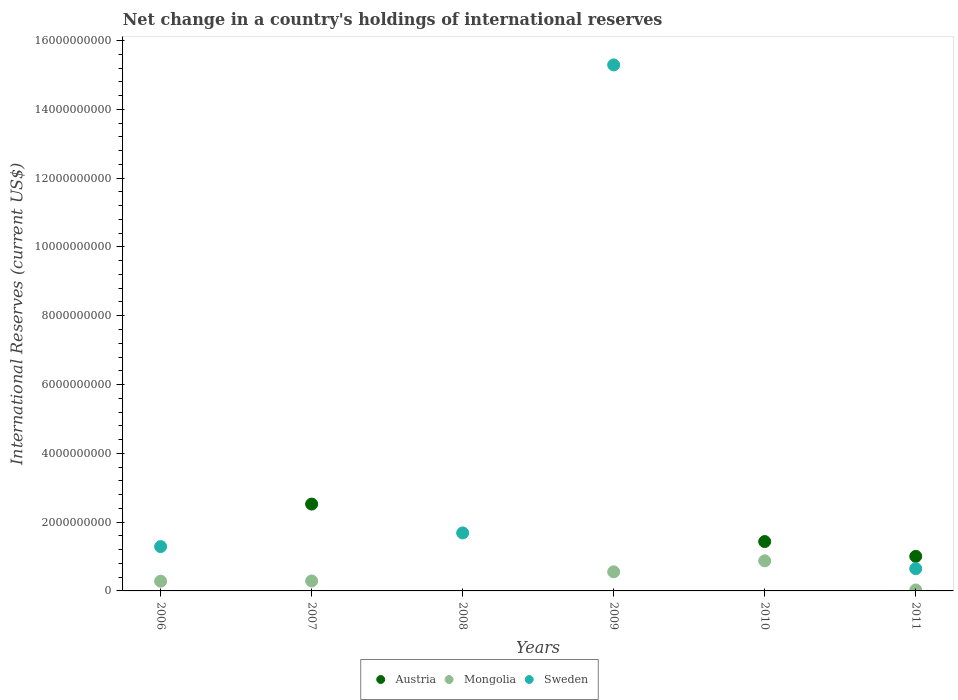How many different coloured dotlines are there?
Your answer should be very brief. 3. Across all years, what is the maximum international reserves in Mongolia?
Make the answer very short. 8.75e+08. Across all years, what is the minimum international reserves in Austria?
Offer a terse response. 0. In which year was the international reserves in Mongolia maximum?
Keep it short and to the point. 2010. What is the total international reserves in Austria in the graph?
Provide a short and direct response. 4.96e+09. What is the difference between the international reserves in Austria in 2010 and that in 2011?
Give a very brief answer. 4.30e+08. What is the difference between the international reserves in Sweden in 2006 and the international reserves in Mongolia in 2010?
Give a very brief answer. 4.14e+08. What is the average international reserves in Sweden per year?
Your answer should be compact. 3.15e+09. In the year 2011, what is the difference between the international reserves in Austria and international reserves in Sweden?
Offer a very short reply. 3.58e+08. In how many years, is the international reserves in Mongolia greater than 5600000000 US$?
Keep it short and to the point. 0. What is the ratio of the international reserves in Sweden in 2009 to that in 2011?
Provide a short and direct response. 23.65. Is the international reserves in Mongolia in 2010 less than that in 2011?
Make the answer very short. No. What is the difference between the highest and the second highest international reserves in Sweden?
Give a very brief answer. 1.36e+1. What is the difference between the highest and the lowest international reserves in Mongolia?
Make the answer very short. 8.75e+08. In how many years, is the international reserves in Austria greater than the average international reserves in Austria taken over all years?
Provide a succinct answer. 3. Is the sum of the international reserves in Sweden in 2006 and 2008 greater than the maximum international reserves in Mongolia across all years?
Offer a very short reply. Yes. Is it the case that in every year, the sum of the international reserves in Austria and international reserves in Mongolia  is greater than the international reserves in Sweden?
Give a very brief answer. No. Does the international reserves in Sweden monotonically increase over the years?
Offer a very short reply. No. Is the international reserves in Sweden strictly greater than the international reserves in Mongolia over the years?
Ensure brevity in your answer.  No. Is the international reserves in Sweden strictly less than the international reserves in Mongolia over the years?
Provide a short and direct response. No. How many years are there in the graph?
Give a very brief answer. 6. Are the values on the major ticks of Y-axis written in scientific E-notation?
Give a very brief answer. No. Does the graph contain grids?
Ensure brevity in your answer.  No. Where does the legend appear in the graph?
Your answer should be very brief. Bottom center. How many legend labels are there?
Keep it short and to the point. 3. What is the title of the graph?
Keep it short and to the point. Net change in a country's holdings of international reserves. What is the label or title of the X-axis?
Your response must be concise. Years. What is the label or title of the Y-axis?
Your answer should be very brief. International Reserves (current US$). What is the International Reserves (current US$) in Austria in 2006?
Your answer should be compact. 0. What is the International Reserves (current US$) in Mongolia in 2006?
Make the answer very short. 2.83e+08. What is the International Reserves (current US$) of Sweden in 2006?
Give a very brief answer. 1.29e+09. What is the International Reserves (current US$) of Austria in 2007?
Make the answer very short. 2.53e+09. What is the International Reserves (current US$) of Mongolia in 2007?
Keep it short and to the point. 2.89e+08. What is the International Reserves (current US$) of Sweden in 2008?
Give a very brief answer. 1.69e+09. What is the International Reserves (current US$) of Mongolia in 2009?
Provide a succinct answer. 5.55e+08. What is the International Reserves (current US$) in Sweden in 2009?
Your answer should be very brief. 1.53e+1. What is the International Reserves (current US$) of Austria in 2010?
Offer a terse response. 1.44e+09. What is the International Reserves (current US$) in Mongolia in 2010?
Make the answer very short. 8.75e+08. What is the International Reserves (current US$) of Sweden in 2010?
Ensure brevity in your answer.  0. What is the International Reserves (current US$) of Austria in 2011?
Offer a very short reply. 1.00e+09. What is the International Reserves (current US$) in Mongolia in 2011?
Your response must be concise. 2.79e+07. What is the International Reserves (current US$) of Sweden in 2011?
Your answer should be very brief. 6.47e+08. Across all years, what is the maximum International Reserves (current US$) in Austria?
Offer a very short reply. 2.53e+09. Across all years, what is the maximum International Reserves (current US$) in Mongolia?
Ensure brevity in your answer.  8.75e+08. Across all years, what is the maximum International Reserves (current US$) in Sweden?
Make the answer very short. 1.53e+1. Across all years, what is the minimum International Reserves (current US$) of Austria?
Ensure brevity in your answer.  0. Across all years, what is the minimum International Reserves (current US$) in Mongolia?
Offer a very short reply. 0. What is the total International Reserves (current US$) of Austria in the graph?
Offer a terse response. 4.96e+09. What is the total International Reserves (current US$) of Mongolia in the graph?
Keep it short and to the point. 2.03e+09. What is the total International Reserves (current US$) in Sweden in the graph?
Ensure brevity in your answer.  1.89e+1. What is the difference between the International Reserves (current US$) in Mongolia in 2006 and that in 2007?
Give a very brief answer. -6.62e+06. What is the difference between the International Reserves (current US$) in Sweden in 2006 and that in 2008?
Give a very brief answer. -3.97e+08. What is the difference between the International Reserves (current US$) of Mongolia in 2006 and that in 2009?
Provide a succinct answer. -2.72e+08. What is the difference between the International Reserves (current US$) in Sweden in 2006 and that in 2009?
Offer a terse response. -1.40e+1. What is the difference between the International Reserves (current US$) of Mongolia in 2006 and that in 2010?
Give a very brief answer. -5.92e+08. What is the difference between the International Reserves (current US$) of Mongolia in 2006 and that in 2011?
Your answer should be compact. 2.55e+08. What is the difference between the International Reserves (current US$) of Sweden in 2006 and that in 2011?
Give a very brief answer. 6.42e+08. What is the difference between the International Reserves (current US$) in Mongolia in 2007 and that in 2009?
Your answer should be compact. -2.66e+08. What is the difference between the International Reserves (current US$) of Austria in 2007 and that in 2010?
Your answer should be very brief. 1.09e+09. What is the difference between the International Reserves (current US$) in Mongolia in 2007 and that in 2010?
Offer a terse response. -5.86e+08. What is the difference between the International Reserves (current US$) in Austria in 2007 and that in 2011?
Your response must be concise. 1.52e+09. What is the difference between the International Reserves (current US$) of Mongolia in 2007 and that in 2011?
Give a very brief answer. 2.61e+08. What is the difference between the International Reserves (current US$) in Sweden in 2008 and that in 2009?
Offer a very short reply. -1.36e+1. What is the difference between the International Reserves (current US$) of Sweden in 2008 and that in 2011?
Give a very brief answer. 1.04e+09. What is the difference between the International Reserves (current US$) in Mongolia in 2009 and that in 2010?
Your answer should be compact. -3.20e+08. What is the difference between the International Reserves (current US$) of Mongolia in 2009 and that in 2011?
Your response must be concise. 5.27e+08. What is the difference between the International Reserves (current US$) in Sweden in 2009 and that in 2011?
Provide a succinct answer. 1.46e+1. What is the difference between the International Reserves (current US$) in Austria in 2010 and that in 2011?
Offer a terse response. 4.30e+08. What is the difference between the International Reserves (current US$) of Mongolia in 2010 and that in 2011?
Make the answer very short. 8.47e+08. What is the difference between the International Reserves (current US$) in Mongolia in 2006 and the International Reserves (current US$) in Sweden in 2008?
Offer a very short reply. -1.40e+09. What is the difference between the International Reserves (current US$) in Mongolia in 2006 and the International Reserves (current US$) in Sweden in 2009?
Ensure brevity in your answer.  -1.50e+1. What is the difference between the International Reserves (current US$) in Mongolia in 2006 and the International Reserves (current US$) in Sweden in 2011?
Ensure brevity in your answer.  -3.64e+08. What is the difference between the International Reserves (current US$) in Austria in 2007 and the International Reserves (current US$) in Sweden in 2008?
Offer a terse response. 8.39e+08. What is the difference between the International Reserves (current US$) in Mongolia in 2007 and the International Reserves (current US$) in Sweden in 2008?
Ensure brevity in your answer.  -1.40e+09. What is the difference between the International Reserves (current US$) of Austria in 2007 and the International Reserves (current US$) of Mongolia in 2009?
Offer a very short reply. 1.97e+09. What is the difference between the International Reserves (current US$) of Austria in 2007 and the International Reserves (current US$) of Sweden in 2009?
Your response must be concise. -1.28e+1. What is the difference between the International Reserves (current US$) of Mongolia in 2007 and the International Reserves (current US$) of Sweden in 2009?
Provide a short and direct response. -1.50e+1. What is the difference between the International Reserves (current US$) of Austria in 2007 and the International Reserves (current US$) of Mongolia in 2010?
Offer a very short reply. 1.65e+09. What is the difference between the International Reserves (current US$) in Austria in 2007 and the International Reserves (current US$) in Mongolia in 2011?
Your response must be concise. 2.50e+09. What is the difference between the International Reserves (current US$) in Austria in 2007 and the International Reserves (current US$) in Sweden in 2011?
Make the answer very short. 1.88e+09. What is the difference between the International Reserves (current US$) of Mongolia in 2007 and the International Reserves (current US$) of Sweden in 2011?
Ensure brevity in your answer.  -3.58e+08. What is the difference between the International Reserves (current US$) of Mongolia in 2009 and the International Reserves (current US$) of Sweden in 2011?
Give a very brief answer. -9.20e+07. What is the difference between the International Reserves (current US$) of Austria in 2010 and the International Reserves (current US$) of Mongolia in 2011?
Give a very brief answer. 1.41e+09. What is the difference between the International Reserves (current US$) of Austria in 2010 and the International Reserves (current US$) of Sweden in 2011?
Your response must be concise. 7.88e+08. What is the difference between the International Reserves (current US$) in Mongolia in 2010 and the International Reserves (current US$) in Sweden in 2011?
Your response must be concise. 2.28e+08. What is the average International Reserves (current US$) of Austria per year?
Offer a terse response. 8.27e+08. What is the average International Reserves (current US$) of Mongolia per year?
Make the answer very short. 3.38e+08. What is the average International Reserves (current US$) of Sweden per year?
Offer a very short reply. 3.15e+09. In the year 2006, what is the difference between the International Reserves (current US$) of Mongolia and International Reserves (current US$) of Sweden?
Make the answer very short. -1.01e+09. In the year 2007, what is the difference between the International Reserves (current US$) of Austria and International Reserves (current US$) of Mongolia?
Your response must be concise. 2.24e+09. In the year 2009, what is the difference between the International Reserves (current US$) in Mongolia and International Reserves (current US$) in Sweden?
Ensure brevity in your answer.  -1.47e+1. In the year 2010, what is the difference between the International Reserves (current US$) of Austria and International Reserves (current US$) of Mongolia?
Offer a terse response. 5.60e+08. In the year 2011, what is the difference between the International Reserves (current US$) of Austria and International Reserves (current US$) of Mongolia?
Provide a short and direct response. 9.77e+08. In the year 2011, what is the difference between the International Reserves (current US$) of Austria and International Reserves (current US$) of Sweden?
Your response must be concise. 3.58e+08. In the year 2011, what is the difference between the International Reserves (current US$) in Mongolia and International Reserves (current US$) in Sweden?
Your response must be concise. -6.19e+08. What is the ratio of the International Reserves (current US$) of Mongolia in 2006 to that in 2007?
Your response must be concise. 0.98. What is the ratio of the International Reserves (current US$) of Sweden in 2006 to that in 2008?
Make the answer very short. 0.76. What is the ratio of the International Reserves (current US$) in Mongolia in 2006 to that in 2009?
Your response must be concise. 0.51. What is the ratio of the International Reserves (current US$) of Sweden in 2006 to that in 2009?
Offer a very short reply. 0.08. What is the ratio of the International Reserves (current US$) in Mongolia in 2006 to that in 2010?
Keep it short and to the point. 0.32. What is the ratio of the International Reserves (current US$) of Mongolia in 2006 to that in 2011?
Your answer should be compact. 10.13. What is the ratio of the International Reserves (current US$) of Sweden in 2006 to that in 2011?
Offer a terse response. 1.99. What is the ratio of the International Reserves (current US$) of Mongolia in 2007 to that in 2009?
Offer a terse response. 0.52. What is the ratio of the International Reserves (current US$) in Austria in 2007 to that in 2010?
Provide a succinct answer. 1.76. What is the ratio of the International Reserves (current US$) of Mongolia in 2007 to that in 2010?
Keep it short and to the point. 0.33. What is the ratio of the International Reserves (current US$) in Austria in 2007 to that in 2011?
Offer a terse response. 2.51. What is the ratio of the International Reserves (current US$) in Mongolia in 2007 to that in 2011?
Your answer should be very brief. 10.37. What is the ratio of the International Reserves (current US$) in Sweden in 2008 to that in 2009?
Keep it short and to the point. 0.11. What is the ratio of the International Reserves (current US$) of Sweden in 2008 to that in 2011?
Provide a succinct answer. 2.61. What is the ratio of the International Reserves (current US$) in Mongolia in 2009 to that in 2010?
Offer a very short reply. 0.63. What is the ratio of the International Reserves (current US$) of Mongolia in 2009 to that in 2011?
Keep it short and to the point. 19.89. What is the ratio of the International Reserves (current US$) in Sweden in 2009 to that in 2011?
Offer a terse response. 23.65. What is the ratio of the International Reserves (current US$) of Austria in 2010 to that in 2011?
Provide a succinct answer. 1.43. What is the ratio of the International Reserves (current US$) in Mongolia in 2010 to that in 2011?
Offer a terse response. 31.36. What is the difference between the highest and the second highest International Reserves (current US$) of Austria?
Provide a succinct answer. 1.09e+09. What is the difference between the highest and the second highest International Reserves (current US$) of Mongolia?
Keep it short and to the point. 3.20e+08. What is the difference between the highest and the second highest International Reserves (current US$) in Sweden?
Provide a succinct answer. 1.36e+1. What is the difference between the highest and the lowest International Reserves (current US$) of Austria?
Your answer should be very brief. 2.53e+09. What is the difference between the highest and the lowest International Reserves (current US$) of Mongolia?
Give a very brief answer. 8.75e+08. What is the difference between the highest and the lowest International Reserves (current US$) in Sweden?
Provide a succinct answer. 1.53e+1. 